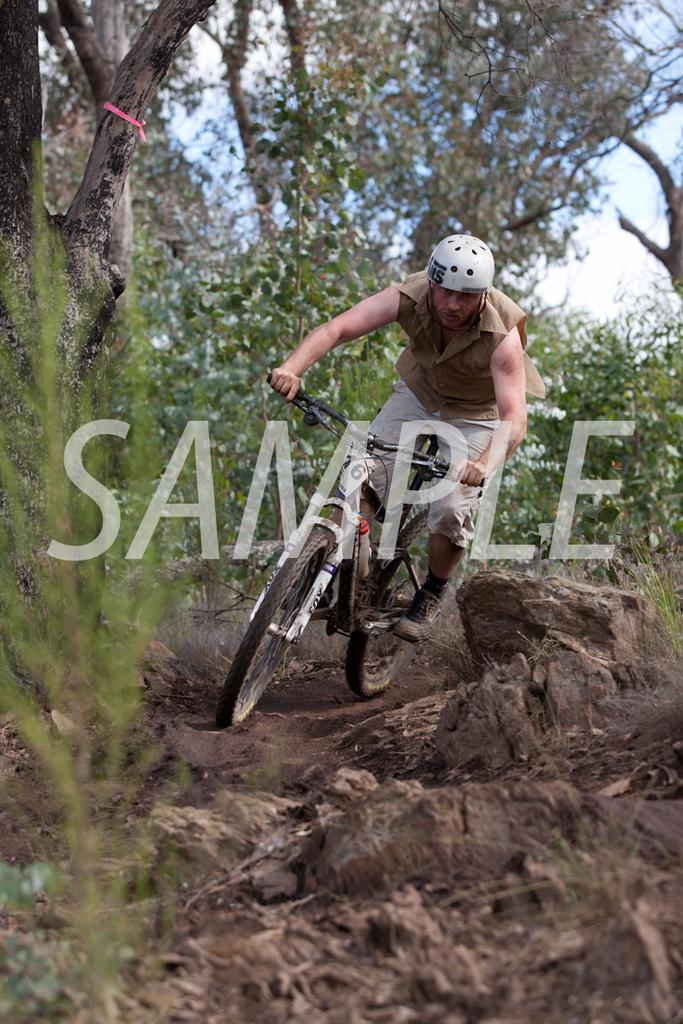What is the main subject of the image? The main subject of the image is a man. What is the man doing in the image? The man is riding a bicycle in the image. What safety precaution is the man taking while riding the bicycle? The man is wearing a helmet in the image. What is the terrain like where the man is riding the bicycle? The bicycle is on mud in the image. What can be seen in the background of the image? There is a tree and the sky visible in the background of the image. What type of fruit is the man holding while riding the bicycle in the image? There is no fruit present in the image; the man is riding a bicycle and wearing a helmet. Where is the meeting taking place in the image? There is no meeting depicted in the image; it shows a man riding a bicycle on mud. 